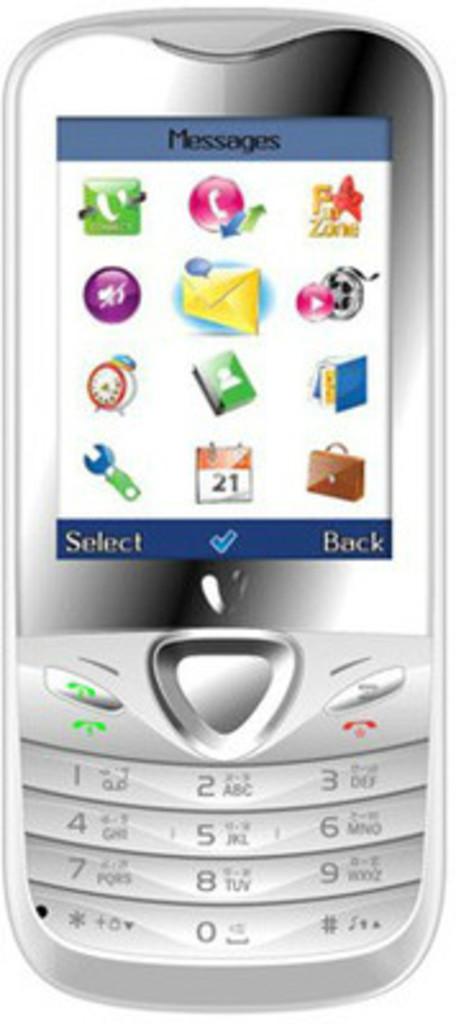Is the back option located at the bottom right of the screen?
Offer a very short reply. Yes. 